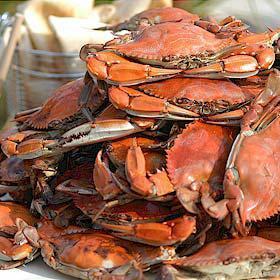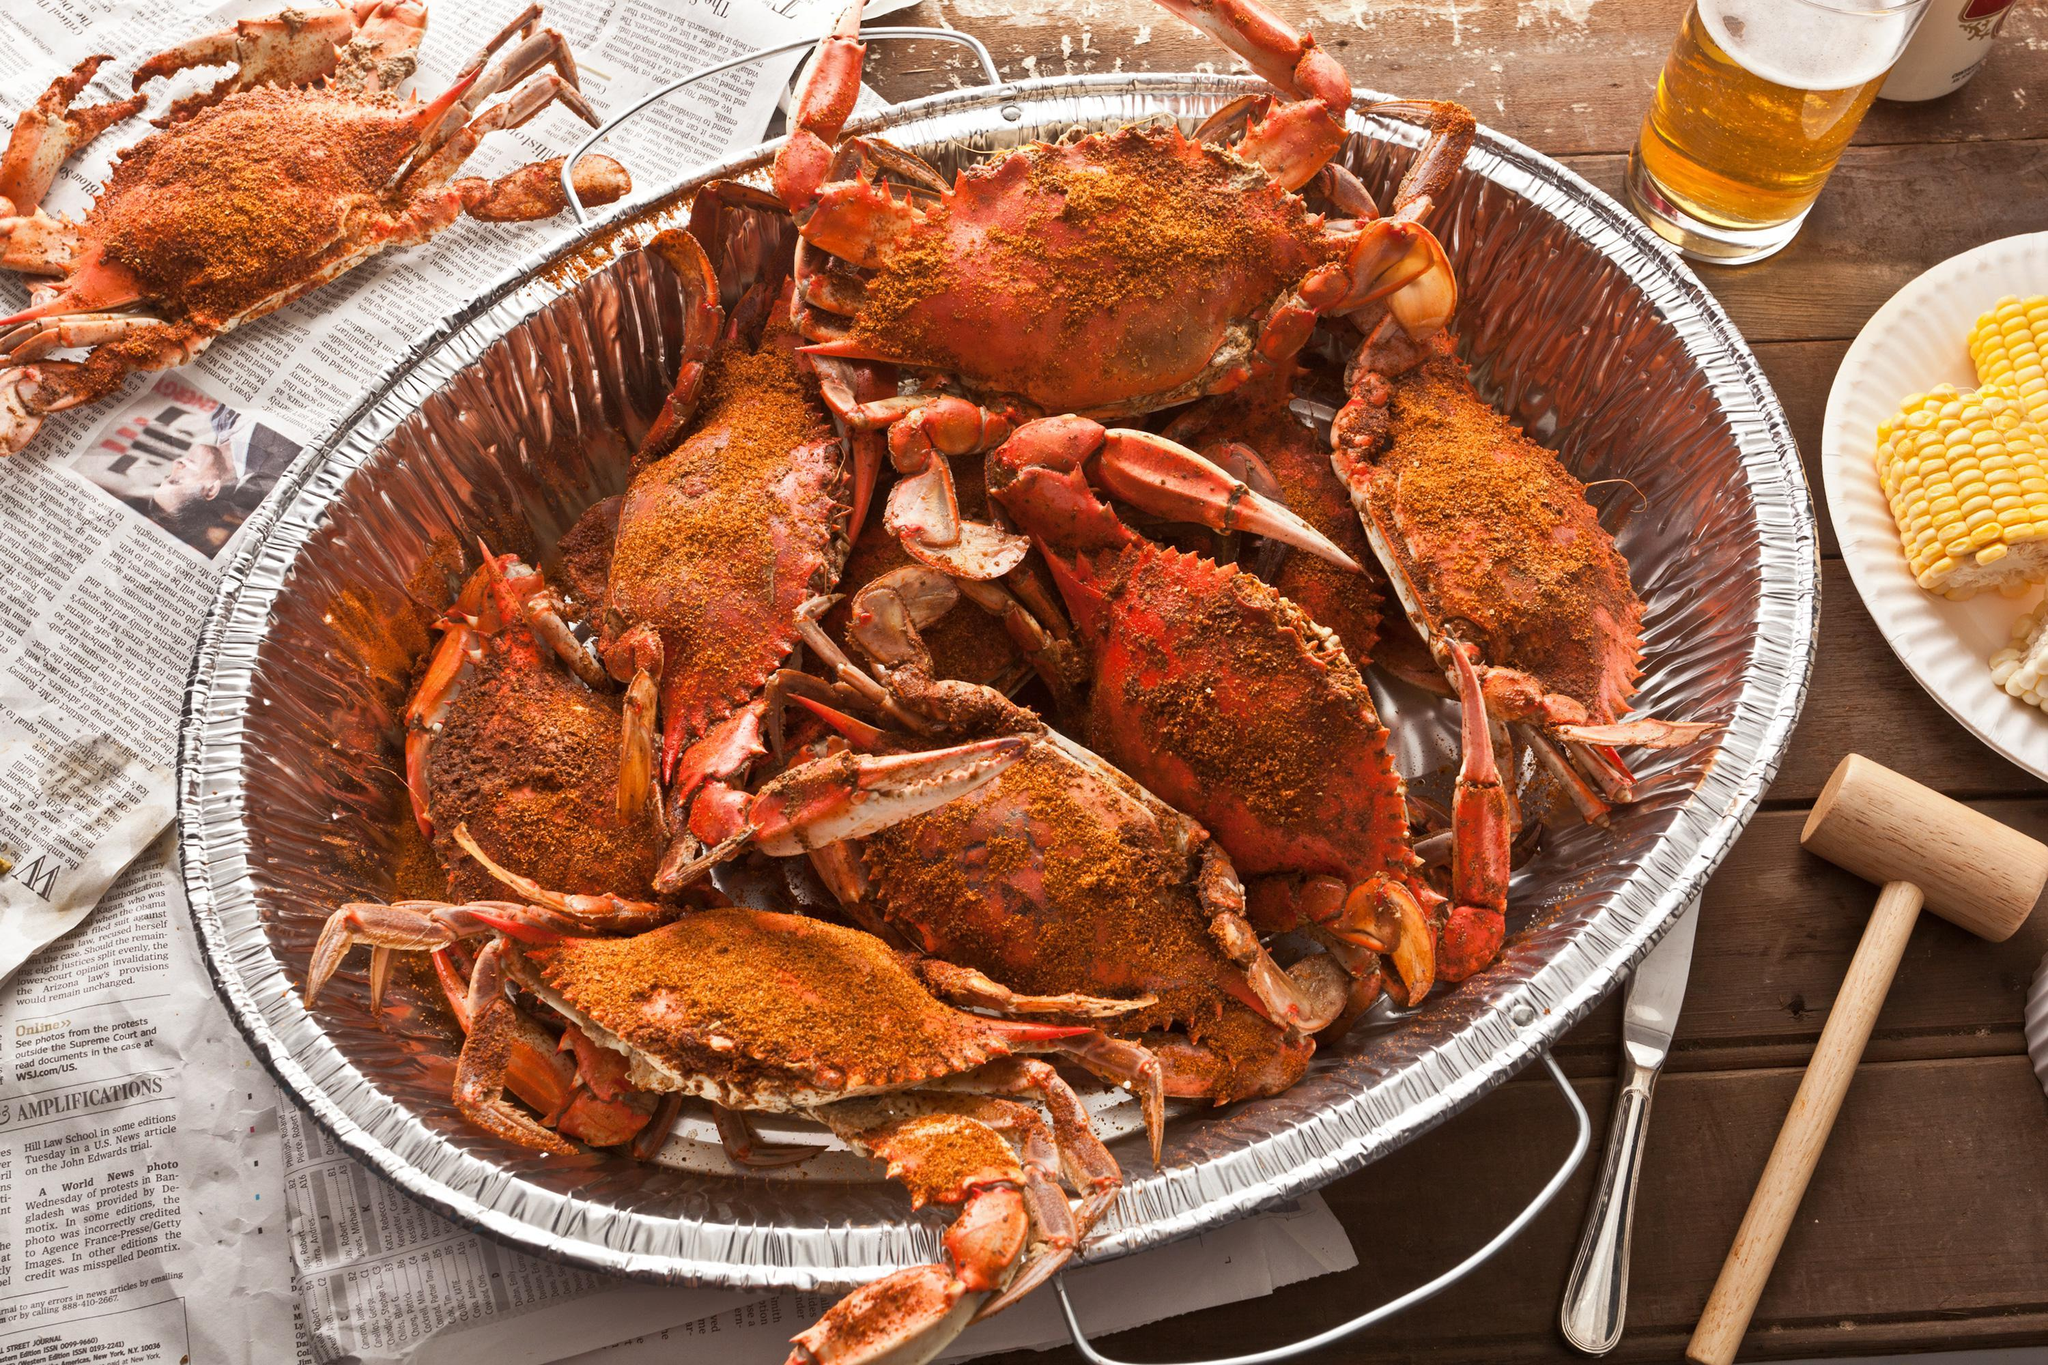The first image is the image on the left, the second image is the image on the right. Evaluate the accuracy of this statement regarding the images: "A meal of crabs sits near an alcoholic beverage in one of the images.". Is it true? Answer yes or no. Yes. The first image is the image on the left, the second image is the image on the right. Analyze the images presented: Is the assertion "One image shows forward facing red-orange crabs stacked up on chunky chips of ice instead of shaved ice." valid? Answer yes or no. No. 